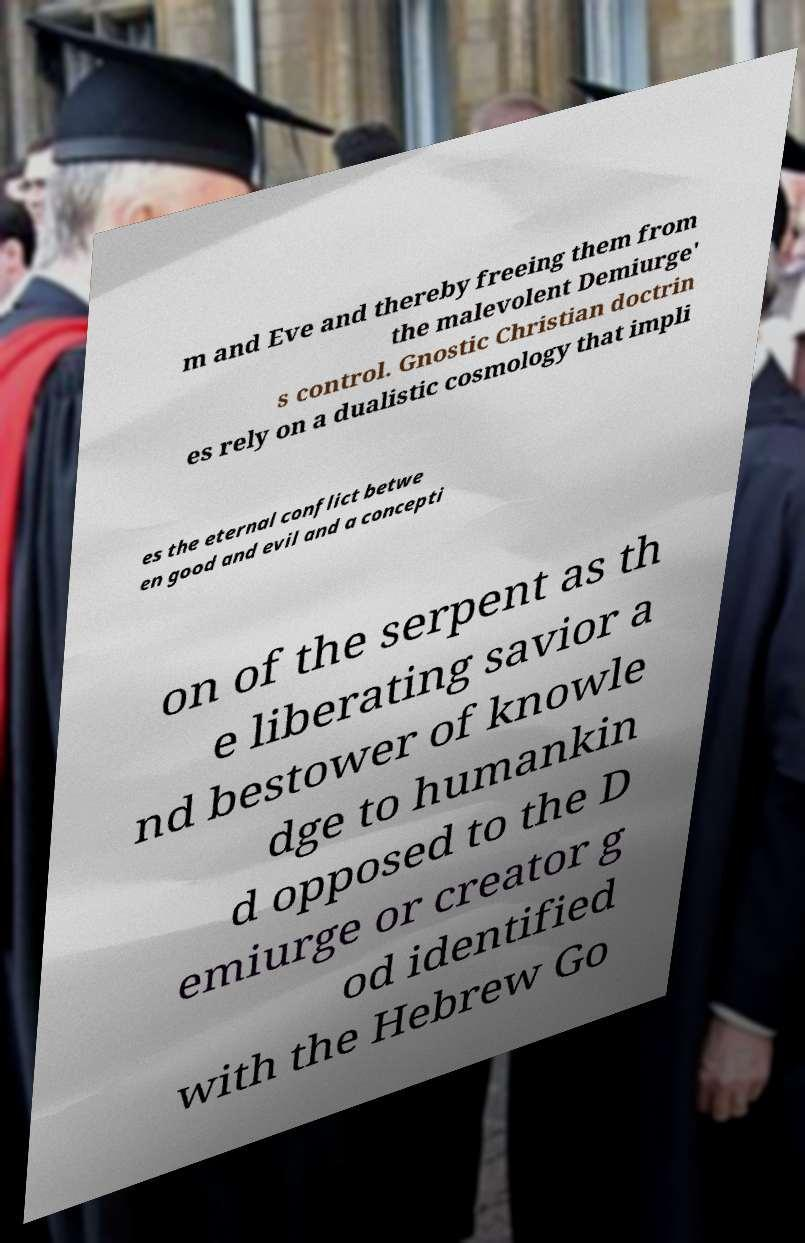Could you extract and type out the text from this image? m and Eve and thereby freeing them from the malevolent Demiurge' s control. Gnostic Christian doctrin es rely on a dualistic cosmology that impli es the eternal conflict betwe en good and evil and a concepti on of the serpent as th e liberating savior a nd bestower of knowle dge to humankin d opposed to the D emiurge or creator g od identified with the Hebrew Go 